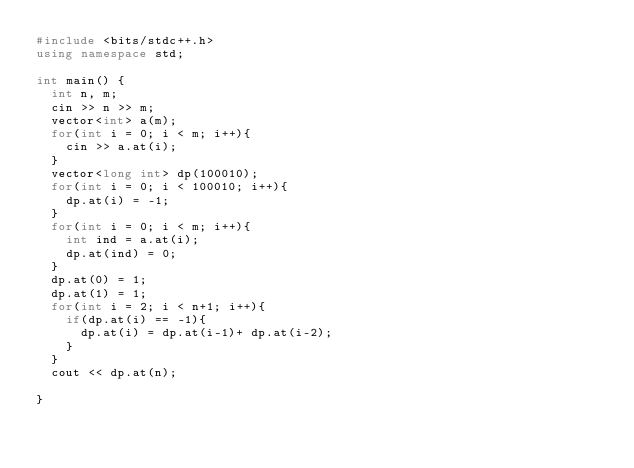Convert code to text. <code><loc_0><loc_0><loc_500><loc_500><_C++_>#include <bits/stdc++.h>
using namespace std;

int main() {
  int n, m;
  cin >> n >> m;
  vector<int> a(m);
  for(int i = 0; i < m; i++){
    cin >> a.at(i);
  }
  vector<long int> dp(100010);
  for(int i = 0; i < 100010; i++){
    dp.at(i) = -1;
  }
  for(int i = 0; i < m; i++){
    int ind = a.at(i); 
    dp.at(ind) = 0;
  }
  dp.at(0) = 1;
  dp.at(1) = 1;
  for(int i = 2; i < n+1; i++){
    if(dp.at(i) == -1){
      dp.at(i) = dp.at(i-1)+ dp.at(i-2);
    }
  }
  cout << dp.at(n);
  
}</code> 